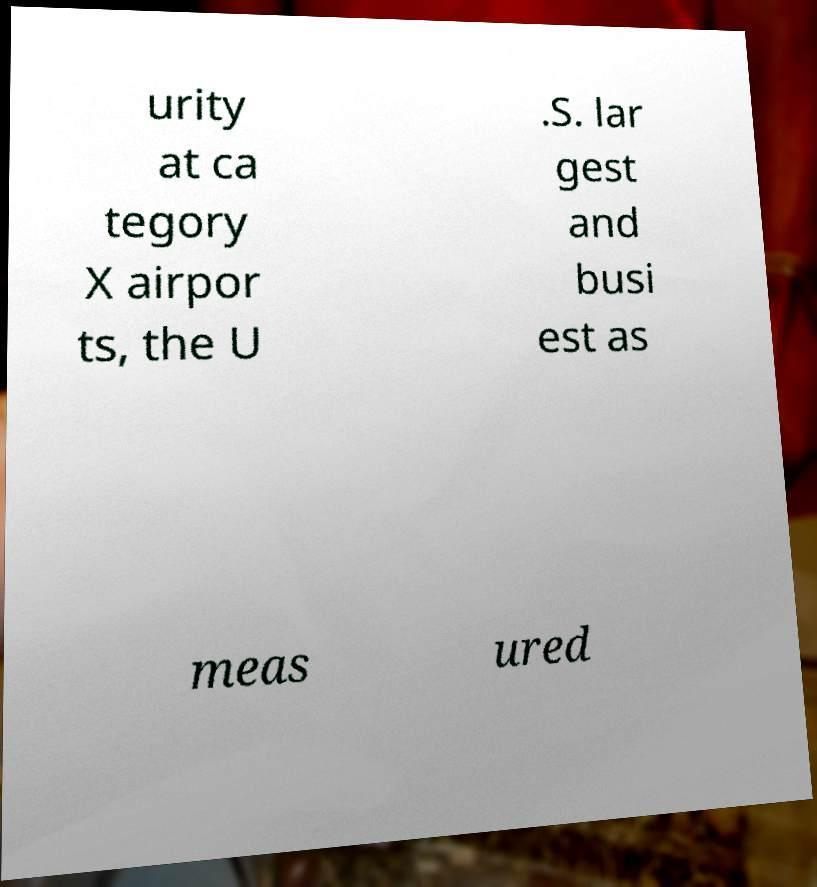Please identify and transcribe the text found in this image. urity at ca tegory X airpor ts, the U .S. lar gest and busi est as meas ured 